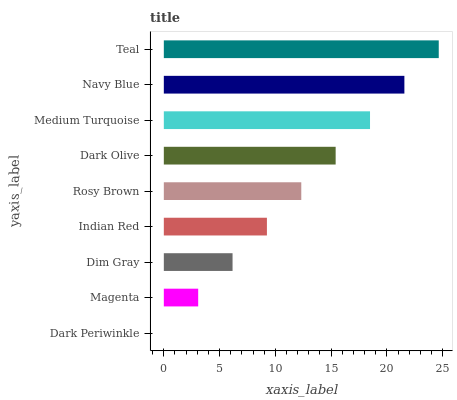Is Dark Periwinkle the minimum?
Answer yes or no. Yes. Is Teal the maximum?
Answer yes or no. Yes. Is Magenta the minimum?
Answer yes or no. No. Is Magenta the maximum?
Answer yes or no. No. Is Magenta greater than Dark Periwinkle?
Answer yes or no. Yes. Is Dark Periwinkle less than Magenta?
Answer yes or no. Yes. Is Dark Periwinkle greater than Magenta?
Answer yes or no. No. Is Magenta less than Dark Periwinkle?
Answer yes or no. No. Is Rosy Brown the high median?
Answer yes or no. Yes. Is Rosy Brown the low median?
Answer yes or no. Yes. Is Navy Blue the high median?
Answer yes or no. No. Is Dark Olive the low median?
Answer yes or no. No. 